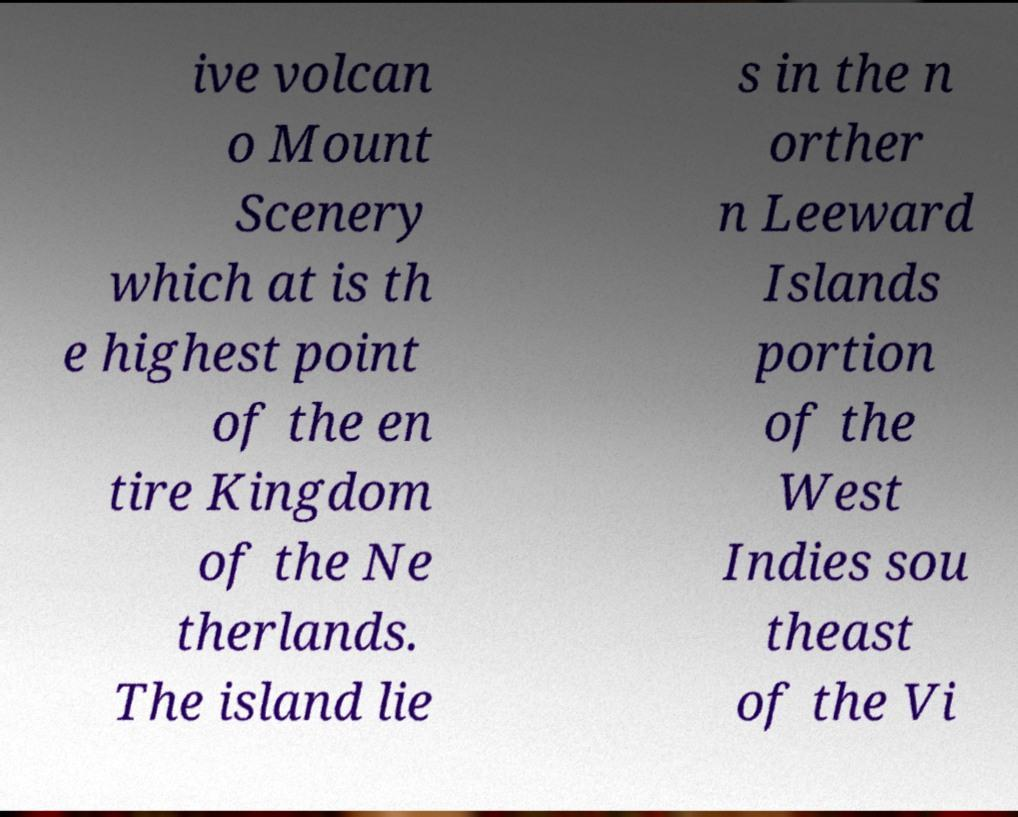For documentation purposes, I need the text within this image transcribed. Could you provide that? ive volcan o Mount Scenery which at is th e highest point of the en tire Kingdom of the Ne therlands. The island lie s in the n orther n Leeward Islands portion of the West Indies sou theast of the Vi 